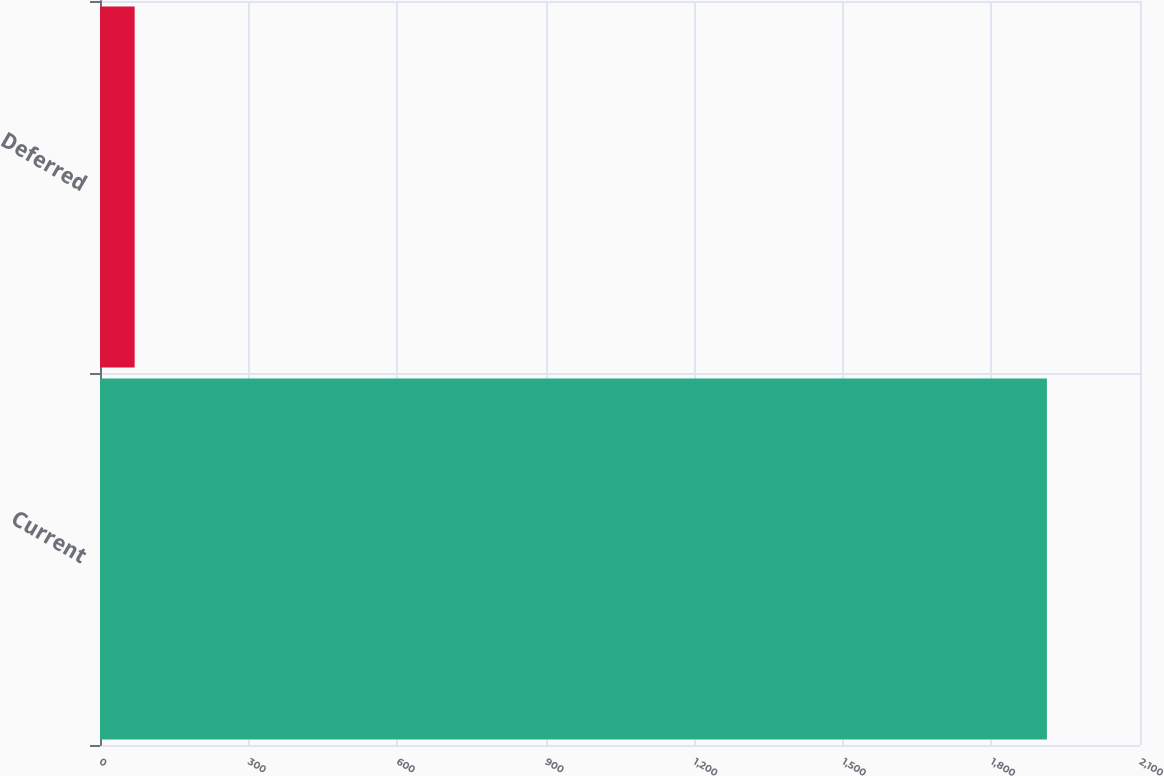Convert chart to OTSL. <chart><loc_0><loc_0><loc_500><loc_500><bar_chart><fcel>Current<fcel>Deferred<nl><fcel>1912<fcel>70<nl></chart> 